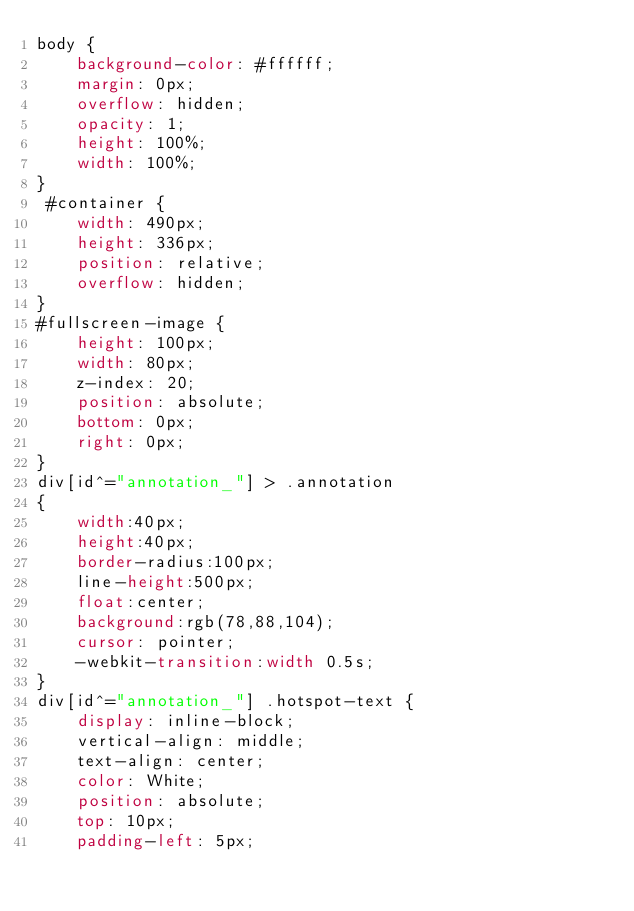<code> <loc_0><loc_0><loc_500><loc_500><_CSS_>body {
    background-color: #ffffff;
    margin: 0px;
    overflow: hidden;
    opacity: 1;
    height: 100%;
    width: 100%;
}
 #container {
    width: 490px;
    height: 336px;
    position: relative;
    overflow: hidden;
}
#fullscreen-image {
    height: 100px;
    width: 80px;
    z-index: 20;
    position: absolute;
    bottom: 0px;
    right: 0px;
}
div[id^="annotation_"] > .annotation
{
    width:40px;
    height:40px;
    border-radius:100px;
    line-height:500px;
    float:center;
    background:rgb(78,88,104);
    cursor: pointer;
    -webkit-transition:width 0.5s;
}
div[id^="annotation_"] .hotspot-text {
    display: inline-block;
    vertical-align: middle;
    text-align: center;
    color: White;
    position: absolute;
    top: 10px;
    padding-left: 5px;</code> 